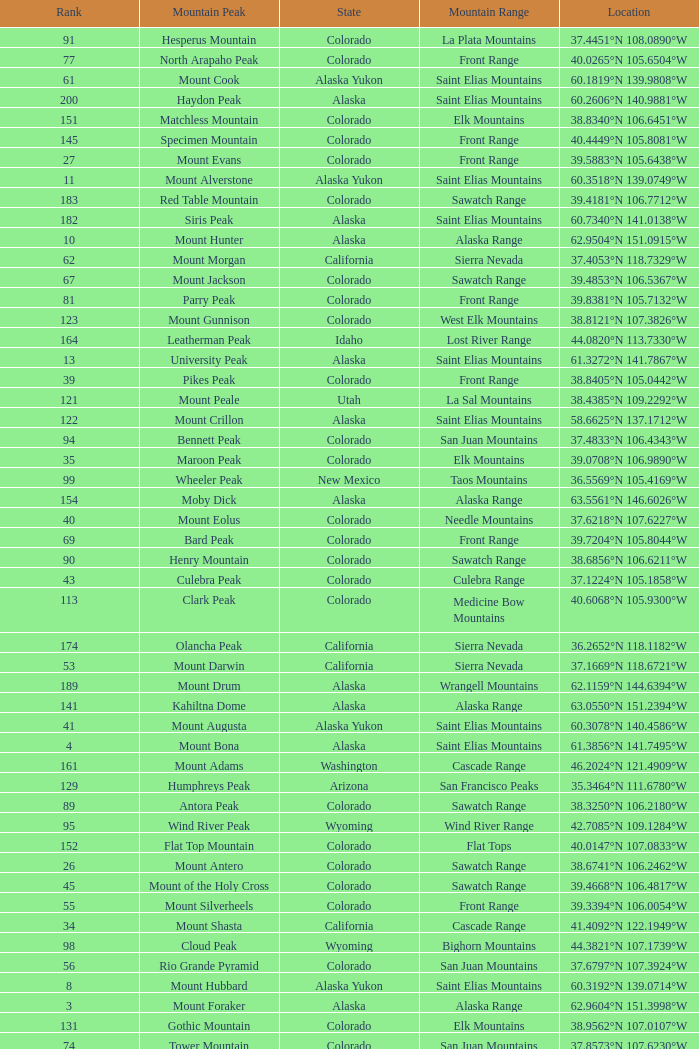What is the mountain peak when the location is 37.5775°n 105.4856°w? Blanca Peak. 